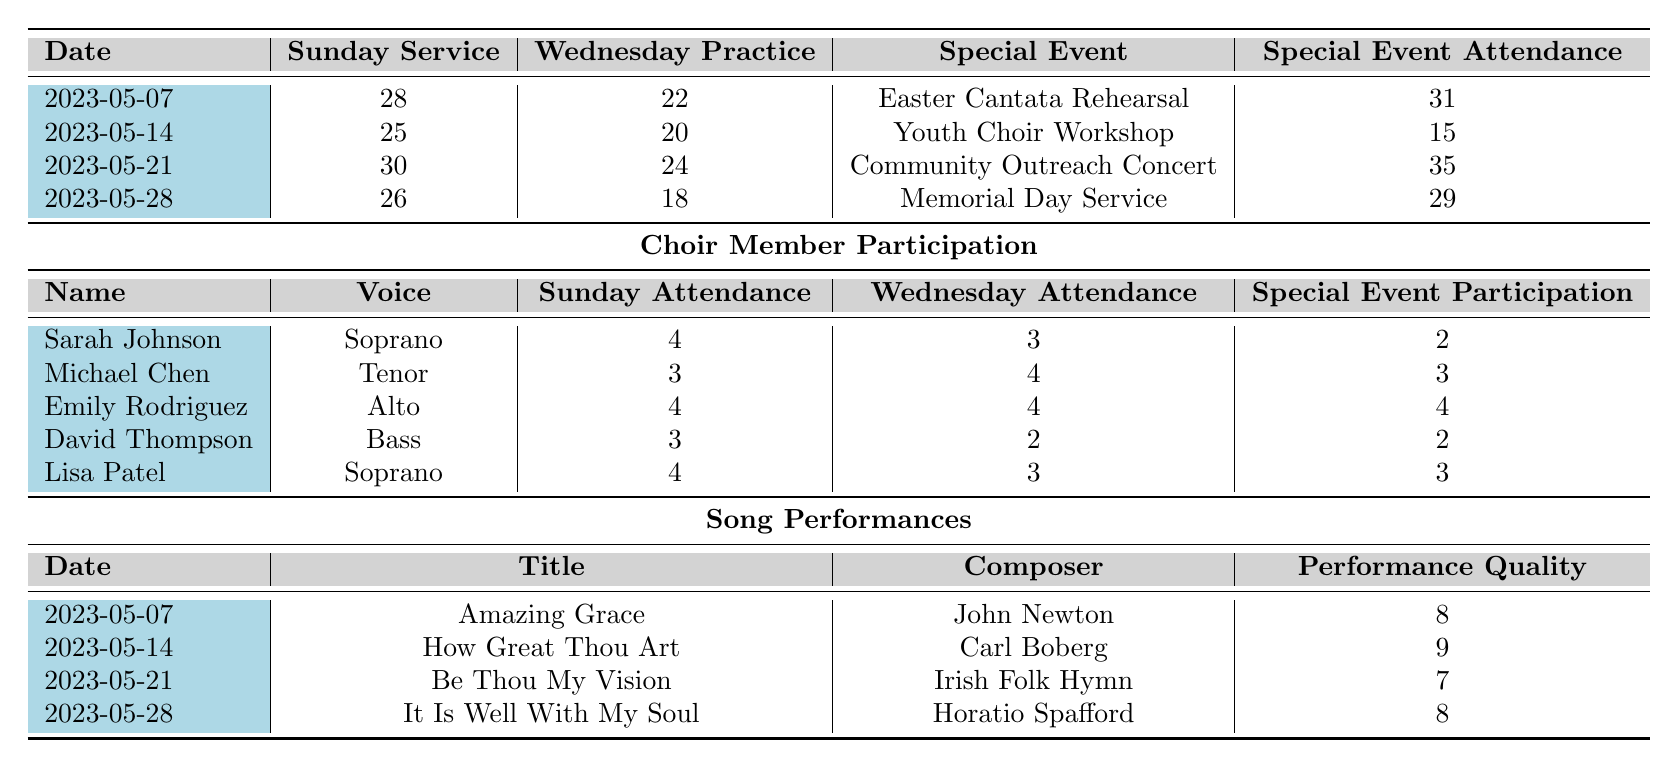What was the highest attendance at a Sunday service in May 2023? The highest attendance at a Sunday service occurred on May 21, with 30 attendees.
Answer: 30 What was the average attendance for Wednesday practices in May 2023? The total attendance for Wednesday practices is (22 + 20 + 24 + 18) = 84. There are 4 data points, so the average is 84/4 = 21.
Answer: 21 Which special event had the lowest attendance? The Youth Choir Workshop had the lowest attendance with 15 attendees.
Answer: Youth Choir Workshop How many times did Sarah Johnson attend Sunday services? Sarah Johnson attended Sunday services 4 times, as indicated in the data.
Answer: 4 What is the total attendance for all special events in May 2023? The total attendance is (31 + 15 + 35 + 29) = 110, summed from each special event attendance.
Answer: 110 Did Emily Rodriguez participate in all special events? Yes, Emily Rodriguez participated in all special events, attending 4 times as shown for special event participation.
Answer: Yes Which song had the highest performance quality, and what was that quality? How Great Thou Art had the highest performance quality at 9, as seen in the performance quality column.
Answer: 9 What is the difference in Sunday service attendance between May 7 and May 14? The difference in attendance is 28 (May 7) - 25 (May 14) = 3.
Answer: 3 How many choir members attended Wednesday practices more than Sunday services? Two members attended Wednesday practices more than Sunday services, specifically Michael Chen and Emily Rodriguez.
Answer: 2 Was there a special event with more attendees than the average Sunday service attendance in May? Yes, the Community Outreach Concert had 35 attendees, which is more than the average Sunday service attendance of 27.25.
Answer: Yes 